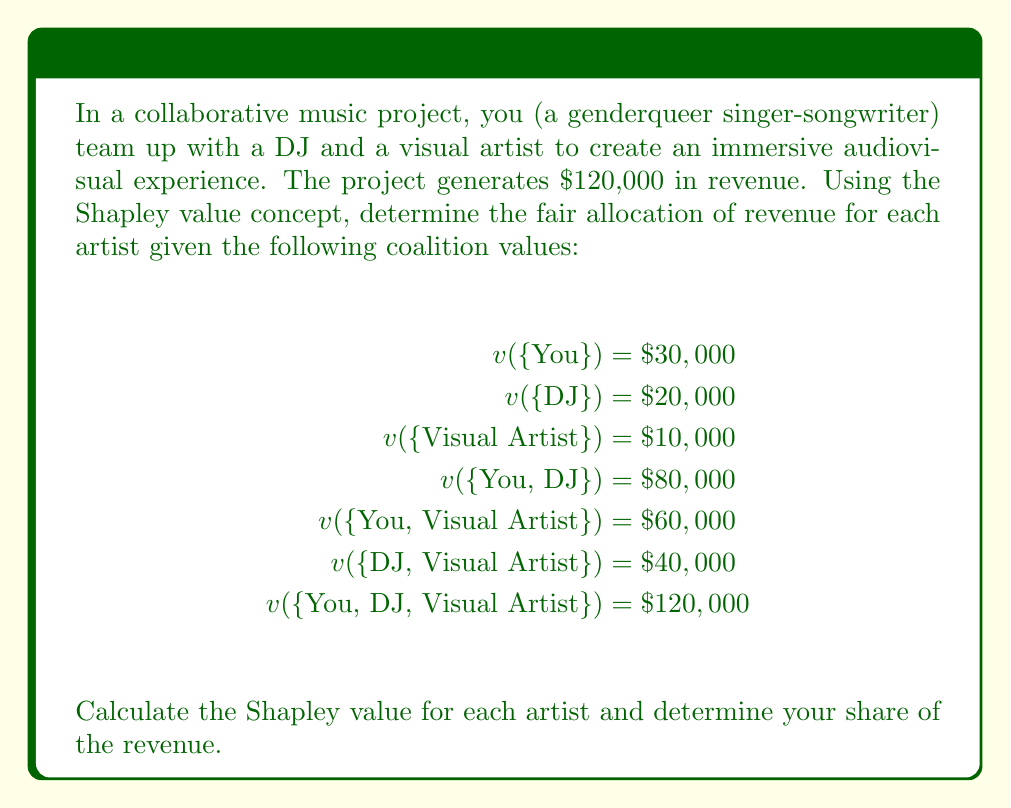Show me your answer to this math problem. To calculate the Shapley value, we need to consider all possible coalition formation orders and calculate the marginal contribution of each player in each order. There are 3! = 6 possible orderings for three players.

Let's denote You as Y, DJ as D, and Visual Artist as V.

Step 1: Calculate marginal contributions for each ordering:

1. Y, D, V: Y: 30,000, D: 50,000, V: 40,000
2. Y, V, D: Y: 30,000, V: 30,000, D: 60,000
3. D, Y, V: D: 20,000, Y: 60,000, V: 40,000
4. D, V, Y: D: 20,000, V: 20,000, Y: 80,000
5. V, Y, D: V: 10,000, Y: 50,000, D: 60,000
6. V, D, Y: V: 10,000, D: 30,000, Y: 80,000

Step 2: Calculate the Shapley value for each player by averaging their marginal contributions:

You (Y):
$$\phi_Y = \frac{30,000 + 30,000 + 60,000 + 80,000 + 50,000 + 80,000}{6} = \$55,000$$

DJ (D):
$$\phi_D = \frac{50,000 + 60,000 + 20,000 + 20,000 + 60,000 + 30,000}{6} = \$40,000$$

Visual Artist (V):
$$\phi_V = \frac{40,000 + 30,000 + 40,000 + 20,000 + 10,000 + 10,000}{6} = \$25,000$$

Step 3: Verify that the sum of Shapley values equals the total coalition value:

$$\phi_Y + \phi_D + \phi_V = 55,000 + 40,000 + 25,000 = \$120,000$$

This matches the total revenue, confirming our calculation is correct.
Answer: Your fair share of the revenue according to the Shapley value is $55,000. 